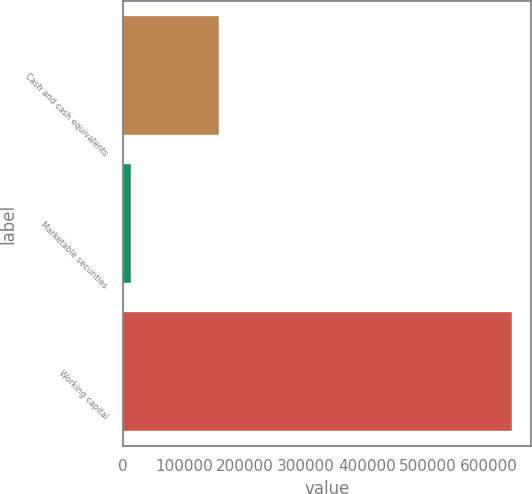Convert chart. <chart><loc_0><loc_0><loc_500><loc_500><bar_chart><fcel>Cash and cash equivalents<fcel>Marketable securities<fcel>Working capital<nl><fcel>157351<fcel>14496<fcel>637296<nl></chart> 